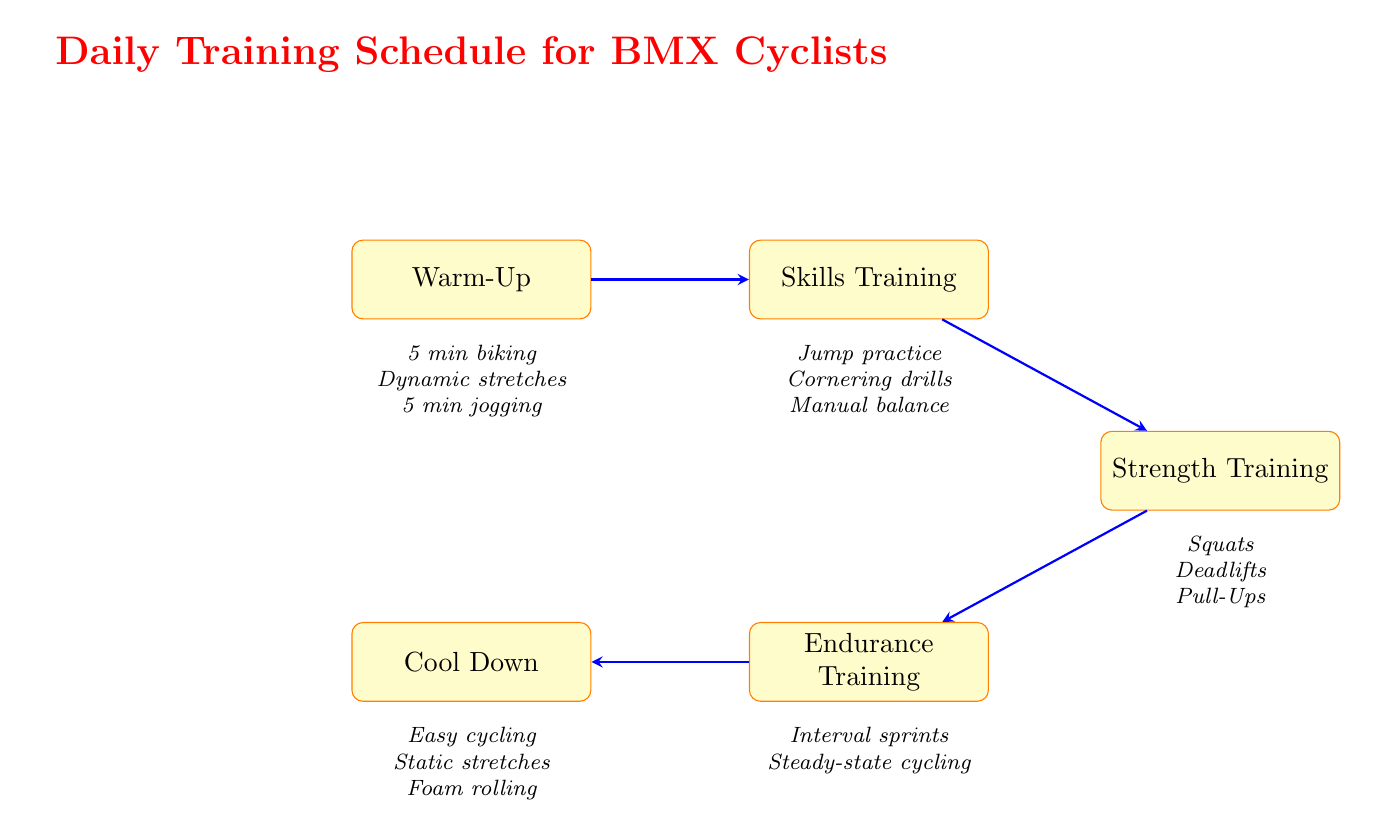What is the first activity in the training schedule? The flow chart indicates that the first node is "Warm-Up," which is the initial activity in the daily training schedule for BMX cyclists.
Answer: Warm-Up How many activities are listed under "Strength Training"? The diagram clearly shows that there are three activities listed under "Strength Training": Squats, Deadlifts, and Pull-Ups.
Answer: 3 What comes after "Endurance Training"? Referring to the arrows in the diagram, the node that follows "Endurance Training" is "Cool Down."
Answer: Cool Down Which two activities are included in "Endurance Training"? The diagram shows two activities listed under "Endurance Training": "30-minute interval sprints" and "20 minutes steady-state cycling."
Answer: Interval sprints, Steady-state cycling What type of exercises are recommended during the "Skills Training" phase? The diagram specifies that "Skills Training" focuses on specific BMX skills, indicating practices like jump practice, cornering drills, and manual balance.
Answer: Jumps, turns How are the nodes connected in the flow chart? The diagram displays a sequential connection where each training phase leads into the next, starting from "Warm-Up" and ending with "Cool Down," forming a linear progression.
Answer: Sequential flow Which activity occurs directly after "Skills Training"? Following the diagram structure, the activity that occurs directly after "Skills Training" is "Strength Training," connected by an arrow.
Answer: Strength Training What is the total number of nodes in the flow chart? By counting each distinct node represented in the diagram, we see there are a total of five nodes related to the training schedule for BMX cyclists.
Answer: 5 What is the purpose of "Cool Down" in the training schedule? The diagram indicates that the purpose of "Cool Down" is to gradually reduce intensity, aiding in body recovery and preventing muscle soreness after training.
Answer: Recovery, prevent soreness 